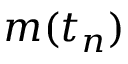Convert formula to latex. <formula><loc_0><loc_0><loc_500><loc_500>m ( t _ { n } )</formula> 